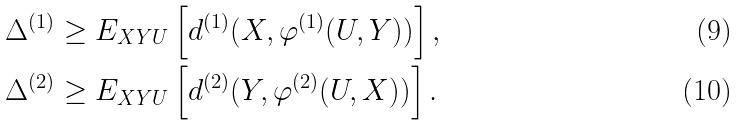Convert formula to latex. <formula><loc_0><loc_0><loc_500><loc_500>\Delta ^ { ( 1 ) } & \geq E _ { X Y U } \left [ d ^ { ( 1 ) } ( X , \varphi ^ { ( 1 ) } ( U , Y ) ) \right ] , \\ \Delta ^ { ( 2 ) } & \geq E _ { X Y U } \left [ d ^ { ( 2 ) } ( Y , \varphi ^ { ( 2 ) } ( U , X ) ) \right ] .</formula> 